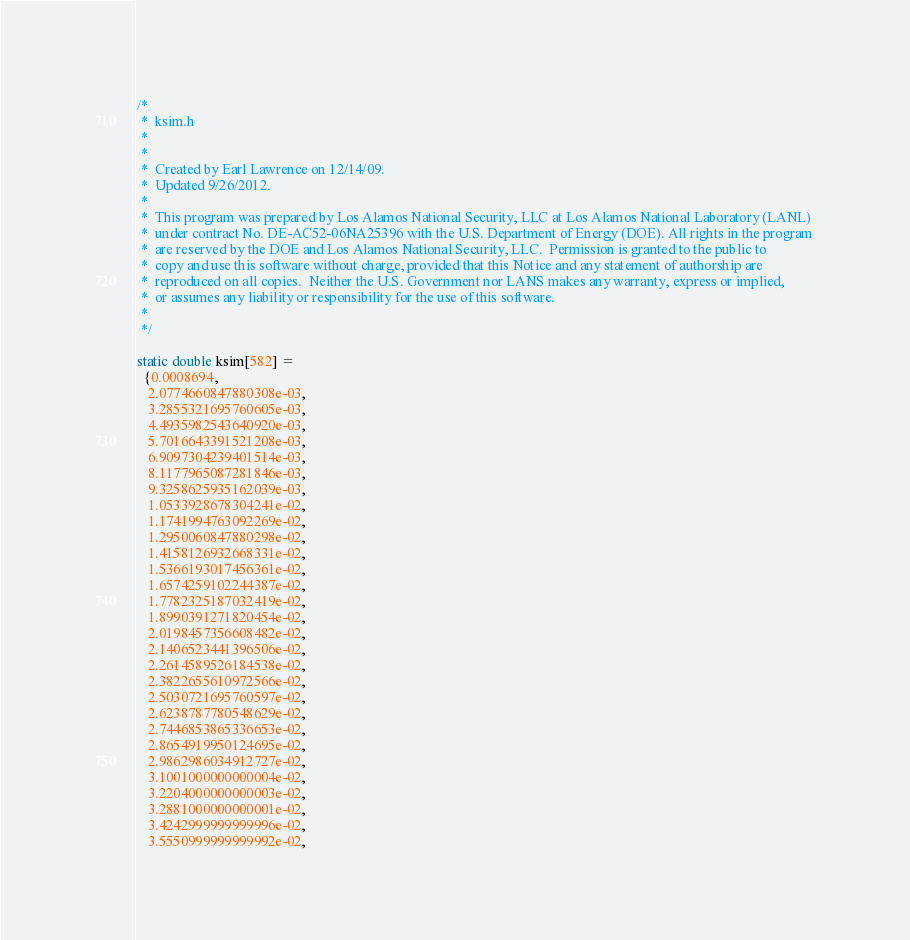<code> <loc_0><loc_0><loc_500><loc_500><_C_>/*
 *  ksim.h
 *  
 *
 *  Created by Earl Lawrence on 12/14/09.
 *  Updated 9/26/2012.
 *
 *  This program was prepared by Los Alamos National Security, LLC at Los Alamos National Laboratory (LANL) 
 *  under contract No. DE-AC52-06NA25396 with the U.S. Department of Energy (DOE). All rights in the program 
 *  are reserved by the DOE and Los Alamos National Security, LLC.  Permission is granted to the public to 
 *  copy and use this software without charge, provided that this Notice and any statement of authorship are 
 *  reproduced on all copies.  Neither the U.S. Government nor LANS makes any warranty, express or implied, 
 *  or assumes any liability or responsibility for the use of this software.
 *
 */

static double ksim[582] = 
  {0.0008694,
   2.0774660847880308e-03,
   3.2855321695760605e-03,
   4.4935982543640920e-03,
   5.7016643391521208e-03,
   6.9097304239401514e-03,
   8.1177965087281846e-03,
   9.3258625935162039e-03,
   1.0533928678304241e-02,
   1.1741994763092269e-02,
   1.2950060847880298e-02,
   1.4158126932668331e-02,
   1.5366193017456361e-02,
   1.6574259102244387e-02,
   1.7782325187032419e-02,
   1.8990391271820454e-02,
   2.0198457356608482e-02,
   2.1406523441396506e-02,
   2.2614589526184538e-02,
   2.3822655610972566e-02,
   2.5030721695760597e-02,
   2.6238787780548629e-02,
   2.7446853865336653e-02,
   2.8654919950124695e-02,
   2.9862986034912727e-02,
   3.1001000000000004e-02,
   3.2204000000000003e-02,
   3.2881000000000001e-02,
   3.4242999999999996e-02,
   3.5550999999999992e-02,</code> 